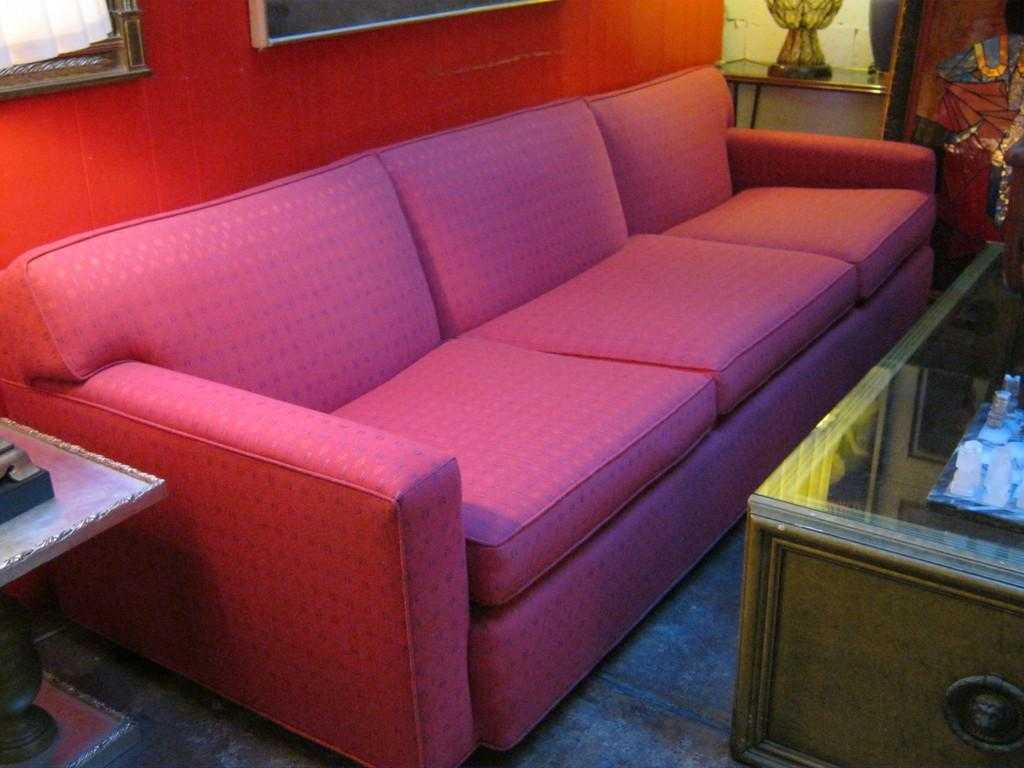What type of furniture is in the image? There is a couch in the image. What is located in front of the couch? There is a table in front of the couch. What color is the wall in the image? The wall in the image has red paint. What is hanging on the wall? There is a photo frame on the wall. How many jellyfish are swimming in the photo frame? There are no jellyfish present in the image, and the photo frame does not depict any aquatic creatures. 